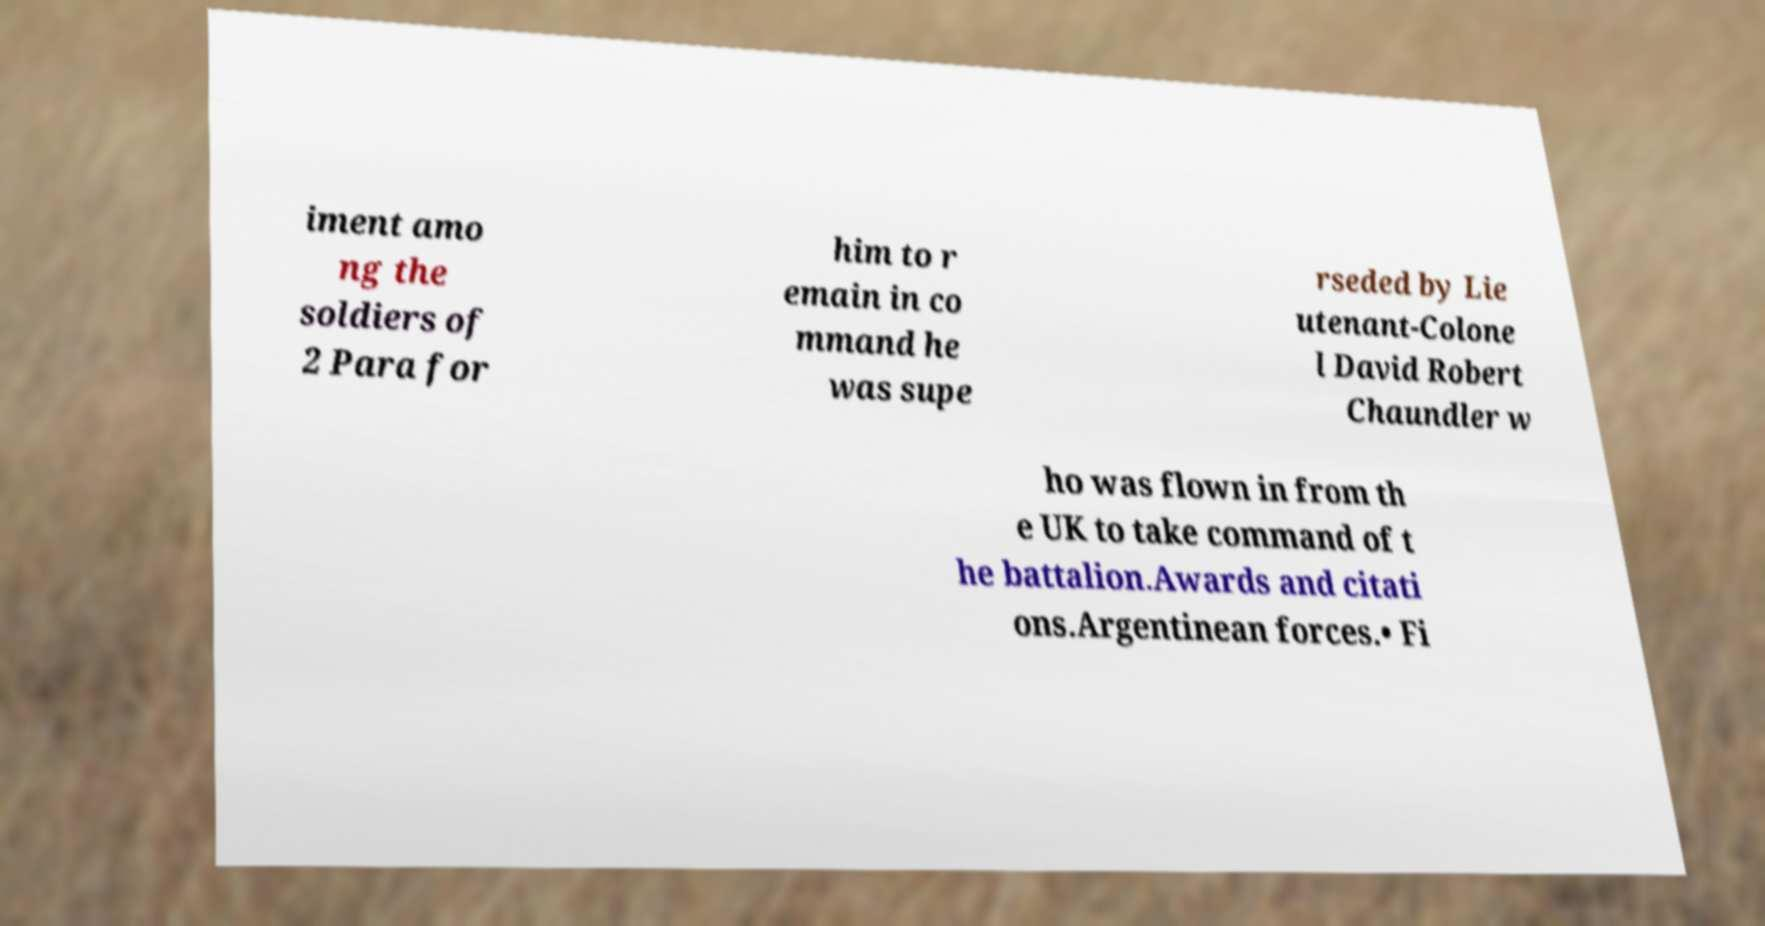For documentation purposes, I need the text within this image transcribed. Could you provide that? iment amo ng the soldiers of 2 Para for him to r emain in co mmand he was supe rseded by Lie utenant-Colone l David Robert Chaundler w ho was flown in from th e UK to take command of t he battalion.Awards and citati ons.Argentinean forces.• Fi 